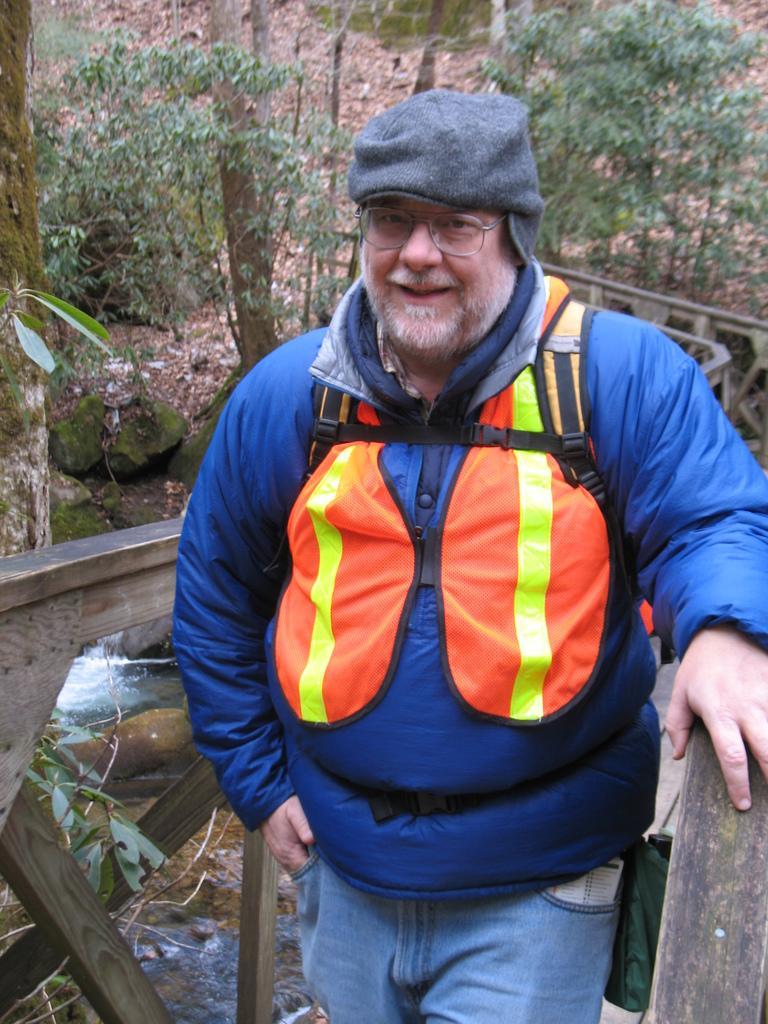Please provide a concise description of this image. In this image there is a person wearing a spectacle, visible may be on in front of fence, behind him there are trees, water, stones, plants visible. 